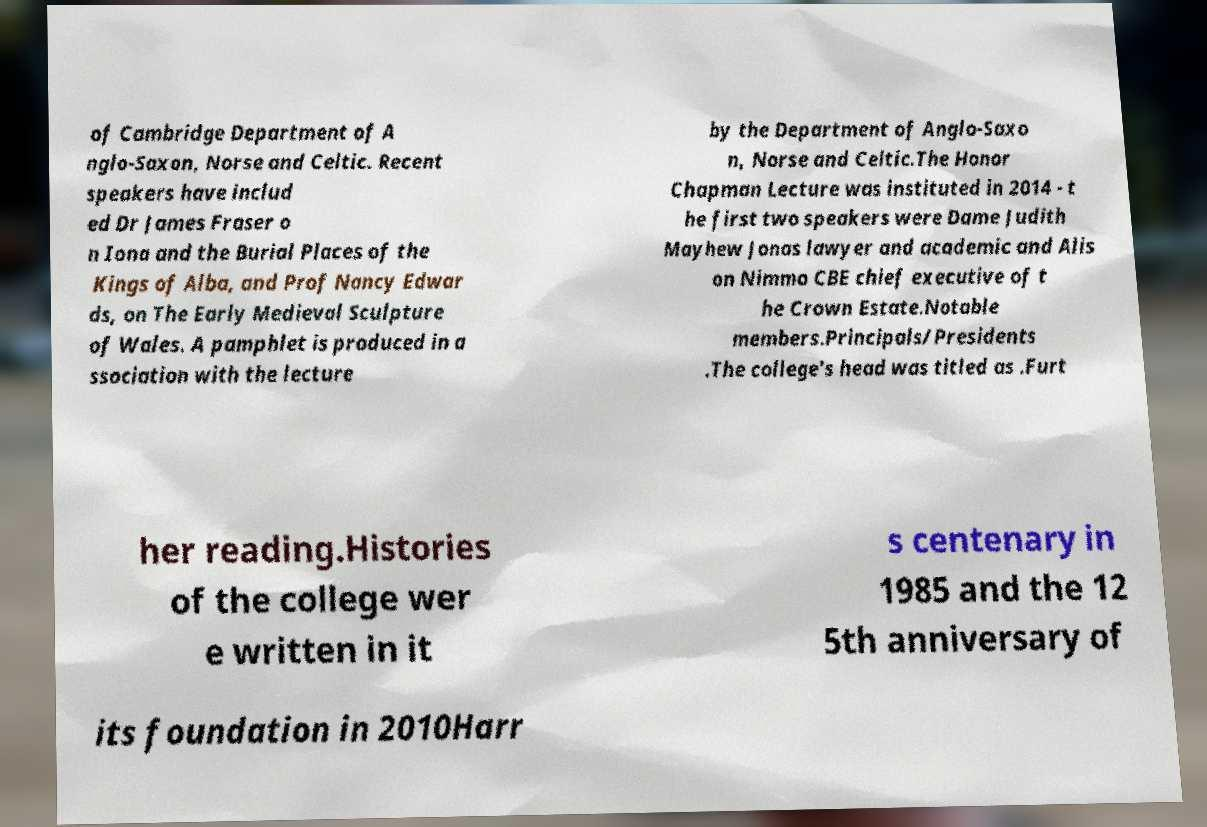There's text embedded in this image that I need extracted. Can you transcribe it verbatim? of Cambridge Department of A nglo-Saxon, Norse and Celtic. Recent speakers have includ ed Dr James Fraser o n Iona and the Burial Places of the Kings of Alba, and Prof Nancy Edwar ds, on The Early Medieval Sculpture of Wales. A pamphlet is produced in a ssociation with the lecture by the Department of Anglo-Saxo n, Norse and Celtic.The Honor Chapman Lecture was instituted in 2014 - t he first two speakers were Dame Judith Mayhew Jonas lawyer and academic and Alis on Nimmo CBE chief executive of t he Crown Estate.Notable members.Principals/Presidents .The college's head was titled as .Furt her reading.Histories of the college wer e written in it s centenary in 1985 and the 12 5th anniversary of its foundation in 2010Harr 